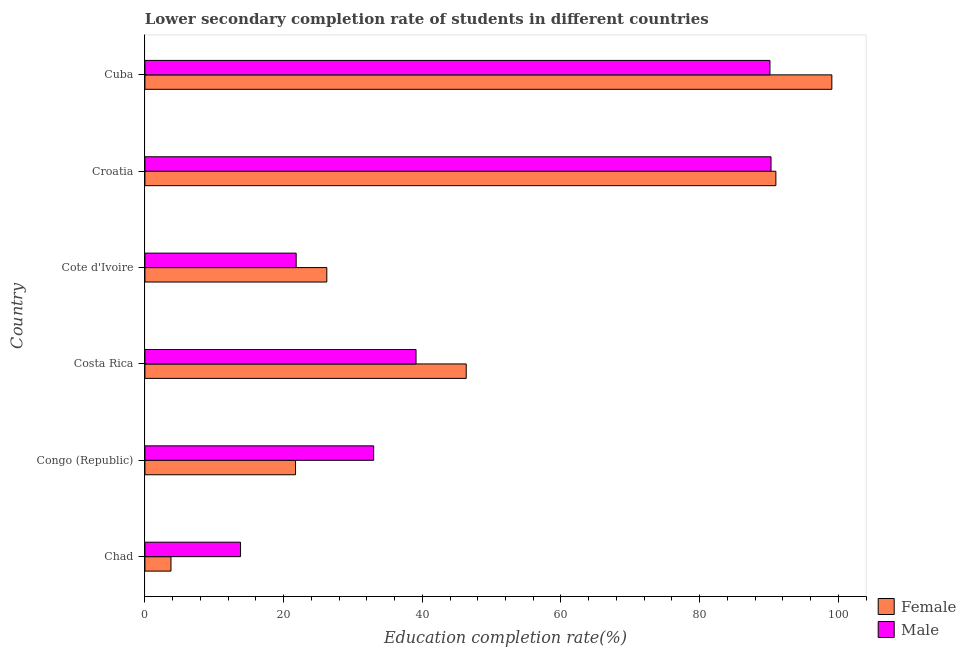How many different coloured bars are there?
Keep it short and to the point. 2. What is the label of the 2nd group of bars from the top?
Provide a succinct answer. Croatia. What is the education completion rate of male students in Costa Rica?
Make the answer very short. 39.1. Across all countries, what is the maximum education completion rate of female students?
Ensure brevity in your answer.  99.07. Across all countries, what is the minimum education completion rate of female students?
Make the answer very short. 3.76. In which country was the education completion rate of female students maximum?
Provide a short and direct response. Cuba. In which country was the education completion rate of male students minimum?
Offer a terse response. Chad. What is the total education completion rate of female students in the graph?
Make the answer very short. 288.11. What is the difference between the education completion rate of female students in Congo (Republic) and that in Cote d'Ivoire?
Keep it short and to the point. -4.51. What is the difference between the education completion rate of male students in Croatia and the education completion rate of female students in Congo (Republic)?
Provide a succinct answer. 68.58. What is the average education completion rate of male students per country?
Provide a short and direct response. 48.02. What is the difference between the education completion rate of male students and education completion rate of female students in Croatia?
Ensure brevity in your answer.  -0.7. In how many countries, is the education completion rate of female students greater than 88 %?
Ensure brevity in your answer.  2. What is the ratio of the education completion rate of female students in Chad to that in Croatia?
Keep it short and to the point. 0.04. Is the difference between the education completion rate of female students in Chad and Congo (Republic) greater than the difference between the education completion rate of male students in Chad and Congo (Republic)?
Keep it short and to the point. Yes. What is the difference between the highest and the second highest education completion rate of male students?
Make the answer very short. 0.16. What is the difference between the highest and the lowest education completion rate of male students?
Keep it short and to the point. 76.51. In how many countries, is the education completion rate of male students greater than the average education completion rate of male students taken over all countries?
Your response must be concise. 2. Is the sum of the education completion rate of male students in Chad and Croatia greater than the maximum education completion rate of female students across all countries?
Offer a terse response. Yes. What does the 1st bar from the top in Croatia represents?
Your answer should be very brief. Male. How many bars are there?
Offer a very short reply. 12. Are all the bars in the graph horizontal?
Offer a terse response. Yes. What is the difference between two consecutive major ticks on the X-axis?
Offer a very short reply. 20. Does the graph contain any zero values?
Provide a short and direct response. No. How many legend labels are there?
Your answer should be very brief. 2. What is the title of the graph?
Provide a succinct answer. Lower secondary completion rate of students in different countries. What is the label or title of the X-axis?
Ensure brevity in your answer.  Education completion rate(%). What is the label or title of the Y-axis?
Ensure brevity in your answer.  Country. What is the Education completion rate(%) in Female in Chad?
Ensure brevity in your answer.  3.76. What is the Education completion rate(%) of Male in Chad?
Offer a terse response. 13.79. What is the Education completion rate(%) of Female in Congo (Republic)?
Offer a terse response. 21.72. What is the Education completion rate(%) in Male in Congo (Republic)?
Offer a terse response. 32.99. What is the Education completion rate(%) of Female in Costa Rica?
Your response must be concise. 46.34. What is the Education completion rate(%) of Male in Costa Rica?
Keep it short and to the point. 39.1. What is the Education completion rate(%) of Female in Cote d'Ivoire?
Make the answer very short. 26.23. What is the Education completion rate(%) in Male in Cote d'Ivoire?
Make the answer very short. 21.82. What is the Education completion rate(%) in Female in Croatia?
Your answer should be very brief. 90.99. What is the Education completion rate(%) of Male in Croatia?
Provide a succinct answer. 90.3. What is the Education completion rate(%) of Female in Cuba?
Offer a terse response. 99.07. What is the Education completion rate(%) in Male in Cuba?
Your answer should be very brief. 90.14. Across all countries, what is the maximum Education completion rate(%) in Female?
Keep it short and to the point. 99.07. Across all countries, what is the maximum Education completion rate(%) of Male?
Offer a very short reply. 90.3. Across all countries, what is the minimum Education completion rate(%) in Female?
Ensure brevity in your answer.  3.76. Across all countries, what is the minimum Education completion rate(%) in Male?
Your response must be concise. 13.79. What is the total Education completion rate(%) of Female in the graph?
Your answer should be compact. 288.11. What is the total Education completion rate(%) in Male in the graph?
Offer a terse response. 288.13. What is the difference between the Education completion rate(%) of Female in Chad and that in Congo (Republic)?
Keep it short and to the point. -17.96. What is the difference between the Education completion rate(%) in Male in Chad and that in Congo (Republic)?
Your answer should be very brief. -19.2. What is the difference between the Education completion rate(%) in Female in Chad and that in Costa Rica?
Offer a terse response. -42.58. What is the difference between the Education completion rate(%) in Male in Chad and that in Costa Rica?
Provide a succinct answer. -25.31. What is the difference between the Education completion rate(%) of Female in Chad and that in Cote d'Ivoire?
Give a very brief answer. -22.47. What is the difference between the Education completion rate(%) of Male in Chad and that in Cote d'Ivoire?
Give a very brief answer. -8.03. What is the difference between the Education completion rate(%) of Female in Chad and that in Croatia?
Offer a terse response. -87.23. What is the difference between the Education completion rate(%) in Male in Chad and that in Croatia?
Offer a terse response. -76.51. What is the difference between the Education completion rate(%) of Female in Chad and that in Cuba?
Your answer should be compact. -95.31. What is the difference between the Education completion rate(%) in Male in Chad and that in Cuba?
Provide a succinct answer. -76.35. What is the difference between the Education completion rate(%) in Female in Congo (Republic) and that in Costa Rica?
Offer a terse response. -24.62. What is the difference between the Education completion rate(%) of Male in Congo (Republic) and that in Costa Rica?
Your answer should be compact. -6.11. What is the difference between the Education completion rate(%) in Female in Congo (Republic) and that in Cote d'Ivoire?
Your answer should be compact. -4.51. What is the difference between the Education completion rate(%) in Male in Congo (Republic) and that in Cote d'Ivoire?
Offer a terse response. 11.17. What is the difference between the Education completion rate(%) in Female in Congo (Republic) and that in Croatia?
Your response must be concise. -69.27. What is the difference between the Education completion rate(%) in Male in Congo (Republic) and that in Croatia?
Offer a terse response. -57.31. What is the difference between the Education completion rate(%) in Female in Congo (Republic) and that in Cuba?
Ensure brevity in your answer.  -77.35. What is the difference between the Education completion rate(%) in Male in Congo (Republic) and that in Cuba?
Make the answer very short. -57.15. What is the difference between the Education completion rate(%) in Female in Costa Rica and that in Cote d'Ivoire?
Your response must be concise. 20.11. What is the difference between the Education completion rate(%) of Male in Costa Rica and that in Cote d'Ivoire?
Ensure brevity in your answer.  17.28. What is the difference between the Education completion rate(%) in Female in Costa Rica and that in Croatia?
Offer a terse response. -44.65. What is the difference between the Education completion rate(%) of Male in Costa Rica and that in Croatia?
Provide a succinct answer. -51.2. What is the difference between the Education completion rate(%) in Female in Costa Rica and that in Cuba?
Make the answer very short. -52.73. What is the difference between the Education completion rate(%) of Male in Costa Rica and that in Cuba?
Offer a terse response. -51.04. What is the difference between the Education completion rate(%) of Female in Cote d'Ivoire and that in Croatia?
Provide a succinct answer. -64.76. What is the difference between the Education completion rate(%) in Male in Cote d'Ivoire and that in Croatia?
Give a very brief answer. -68.48. What is the difference between the Education completion rate(%) in Female in Cote d'Ivoire and that in Cuba?
Offer a terse response. -72.83. What is the difference between the Education completion rate(%) in Male in Cote d'Ivoire and that in Cuba?
Ensure brevity in your answer.  -68.32. What is the difference between the Education completion rate(%) of Female in Croatia and that in Cuba?
Give a very brief answer. -8.07. What is the difference between the Education completion rate(%) in Male in Croatia and that in Cuba?
Your answer should be compact. 0.16. What is the difference between the Education completion rate(%) in Female in Chad and the Education completion rate(%) in Male in Congo (Republic)?
Give a very brief answer. -29.23. What is the difference between the Education completion rate(%) in Female in Chad and the Education completion rate(%) in Male in Costa Rica?
Keep it short and to the point. -35.34. What is the difference between the Education completion rate(%) in Female in Chad and the Education completion rate(%) in Male in Cote d'Ivoire?
Keep it short and to the point. -18.06. What is the difference between the Education completion rate(%) of Female in Chad and the Education completion rate(%) of Male in Croatia?
Ensure brevity in your answer.  -86.54. What is the difference between the Education completion rate(%) of Female in Chad and the Education completion rate(%) of Male in Cuba?
Provide a succinct answer. -86.38. What is the difference between the Education completion rate(%) of Female in Congo (Republic) and the Education completion rate(%) of Male in Costa Rica?
Give a very brief answer. -17.38. What is the difference between the Education completion rate(%) of Female in Congo (Republic) and the Education completion rate(%) of Male in Cote d'Ivoire?
Ensure brevity in your answer.  -0.1. What is the difference between the Education completion rate(%) in Female in Congo (Republic) and the Education completion rate(%) in Male in Croatia?
Provide a short and direct response. -68.58. What is the difference between the Education completion rate(%) of Female in Congo (Republic) and the Education completion rate(%) of Male in Cuba?
Make the answer very short. -68.42. What is the difference between the Education completion rate(%) of Female in Costa Rica and the Education completion rate(%) of Male in Cote d'Ivoire?
Your answer should be very brief. 24.52. What is the difference between the Education completion rate(%) of Female in Costa Rica and the Education completion rate(%) of Male in Croatia?
Your answer should be very brief. -43.96. What is the difference between the Education completion rate(%) of Female in Costa Rica and the Education completion rate(%) of Male in Cuba?
Your answer should be compact. -43.8. What is the difference between the Education completion rate(%) of Female in Cote d'Ivoire and the Education completion rate(%) of Male in Croatia?
Offer a very short reply. -64.06. What is the difference between the Education completion rate(%) of Female in Cote d'Ivoire and the Education completion rate(%) of Male in Cuba?
Your answer should be very brief. -63.91. What is the difference between the Education completion rate(%) of Female in Croatia and the Education completion rate(%) of Male in Cuba?
Ensure brevity in your answer.  0.85. What is the average Education completion rate(%) of Female per country?
Provide a succinct answer. 48.02. What is the average Education completion rate(%) in Male per country?
Offer a very short reply. 48.02. What is the difference between the Education completion rate(%) of Female and Education completion rate(%) of Male in Chad?
Your answer should be very brief. -10.03. What is the difference between the Education completion rate(%) of Female and Education completion rate(%) of Male in Congo (Republic)?
Your answer should be very brief. -11.27. What is the difference between the Education completion rate(%) of Female and Education completion rate(%) of Male in Costa Rica?
Make the answer very short. 7.24. What is the difference between the Education completion rate(%) of Female and Education completion rate(%) of Male in Cote d'Ivoire?
Ensure brevity in your answer.  4.42. What is the difference between the Education completion rate(%) of Female and Education completion rate(%) of Male in Croatia?
Keep it short and to the point. 0.7. What is the difference between the Education completion rate(%) of Female and Education completion rate(%) of Male in Cuba?
Give a very brief answer. 8.93. What is the ratio of the Education completion rate(%) in Female in Chad to that in Congo (Republic)?
Your response must be concise. 0.17. What is the ratio of the Education completion rate(%) in Male in Chad to that in Congo (Republic)?
Your answer should be compact. 0.42. What is the ratio of the Education completion rate(%) in Female in Chad to that in Costa Rica?
Keep it short and to the point. 0.08. What is the ratio of the Education completion rate(%) of Male in Chad to that in Costa Rica?
Offer a terse response. 0.35. What is the ratio of the Education completion rate(%) of Female in Chad to that in Cote d'Ivoire?
Offer a terse response. 0.14. What is the ratio of the Education completion rate(%) in Male in Chad to that in Cote d'Ivoire?
Your answer should be very brief. 0.63. What is the ratio of the Education completion rate(%) in Female in Chad to that in Croatia?
Ensure brevity in your answer.  0.04. What is the ratio of the Education completion rate(%) in Male in Chad to that in Croatia?
Your answer should be very brief. 0.15. What is the ratio of the Education completion rate(%) in Female in Chad to that in Cuba?
Your answer should be compact. 0.04. What is the ratio of the Education completion rate(%) of Male in Chad to that in Cuba?
Offer a terse response. 0.15. What is the ratio of the Education completion rate(%) in Female in Congo (Republic) to that in Costa Rica?
Make the answer very short. 0.47. What is the ratio of the Education completion rate(%) of Male in Congo (Republic) to that in Costa Rica?
Provide a succinct answer. 0.84. What is the ratio of the Education completion rate(%) of Female in Congo (Republic) to that in Cote d'Ivoire?
Make the answer very short. 0.83. What is the ratio of the Education completion rate(%) in Male in Congo (Republic) to that in Cote d'Ivoire?
Your answer should be very brief. 1.51. What is the ratio of the Education completion rate(%) in Female in Congo (Republic) to that in Croatia?
Your response must be concise. 0.24. What is the ratio of the Education completion rate(%) of Male in Congo (Republic) to that in Croatia?
Offer a very short reply. 0.37. What is the ratio of the Education completion rate(%) in Female in Congo (Republic) to that in Cuba?
Provide a succinct answer. 0.22. What is the ratio of the Education completion rate(%) in Male in Congo (Republic) to that in Cuba?
Ensure brevity in your answer.  0.37. What is the ratio of the Education completion rate(%) of Female in Costa Rica to that in Cote d'Ivoire?
Keep it short and to the point. 1.77. What is the ratio of the Education completion rate(%) in Male in Costa Rica to that in Cote d'Ivoire?
Keep it short and to the point. 1.79. What is the ratio of the Education completion rate(%) in Female in Costa Rica to that in Croatia?
Ensure brevity in your answer.  0.51. What is the ratio of the Education completion rate(%) of Male in Costa Rica to that in Croatia?
Ensure brevity in your answer.  0.43. What is the ratio of the Education completion rate(%) in Female in Costa Rica to that in Cuba?
Your response must be concise. 0.47. What is the ratio of the Education completion rate(%) in Male in Costa Rica to that in Cuba?
Your answer should be compact. 0.43. What is the ratio of the Education completion rate(%) in Female in Cote d'Ivoire to that in Croatia?
Ensure brevity in your answer.  0.29. What is the ratio of the Education completion rate(%) in Male in Cote d'Ivoire to that in Croatia?
Offer a terse response. 0.24. What is the ratio of the Education completion rate(%) in Female in Cote d'Ivoire to that in Cuba?
Give a very brief answer. 0.26. What is the ratio of the Education completion rate(%) in Male in Cote d'Ivoire to that in Cuba?
Provide a succinct answer. 0.24. What is the ratio of the Education completion rate(%) in Female in Croatia to that in Cuba?
Your answer should be very brief. 0.92. What is the ratio of the Education completion rate(%) of Male in Croatia to that in Cuba?
Offer a terse response. 1. What is the difference between the highest and the second highest Education completion rate(%) in Female?
Your response must be concise. 8.07. What is the difference between the highest and the second highest Education completion rate(%) in Male?
Ensure brevity in your answer.  0.16. What is the difference between the highest and the lowest Education completion rate(%) in Female?
Your answer should be very brief. 95.31. What is the difference between the highest and the lowest Education completion rate(%) of Male?
Ensure brevity in your answer.  76.51. 